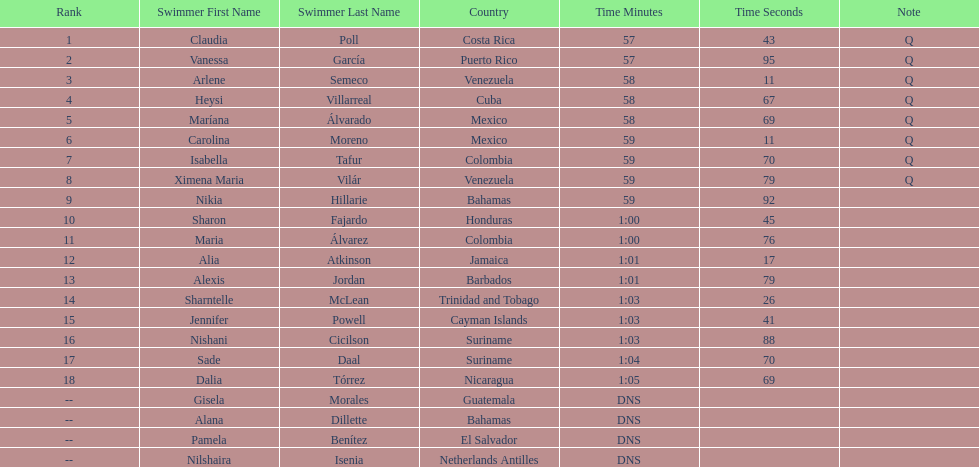How many swimmers are from mexico? 2. 